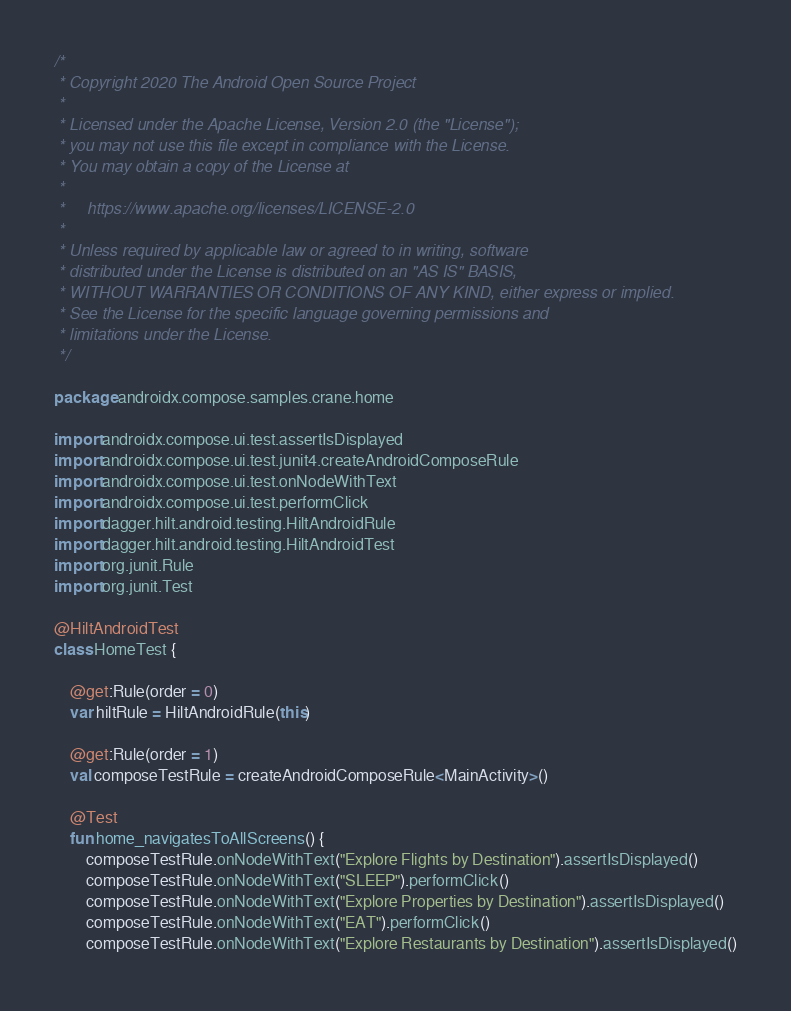<code> <loc_0><loc_0><loc_500><loc_500><_Kotlin_>/*
 * Copyright 2020 The Android Open Source Project
 *
 * Licensed under the Apache License, Version 2.0 (the "License");
 * you may not use this file except in compliance with the License.
 * You may obtain a copy of the License at
 *
 *     https://www.apache.org/licenses/LICENSE-2.0
 *
 * Unless required by applicable law or agreed to in writing, software
 * distributed under the License is distributed on an "AS IS" BASIS,
 * WITHOUT WARRANTIES OR CONDITIONS OF ANY KIND, either express or implied.
 * See the License for the specific language governing permissions and
 * limitations under the License.
 */

package androidx.compose.samples.crane.home

import androidx.compose.ui.test.assertIsDisplayed
import androidx.compose.ui.test.junit4.createAndroidComposeRule
import androidx.compose.ui.test.onNodeWithText
import androidx.compose.ui.test.performClick
import dagger.hilt.android.testing.HiltAndroidRule
import dagger.hilt.android.testing.HiltAndroidTest
import org.junit.Rule
import org.junit.Test

@HiltAndroidTest
class HomeTest {

    @get:Rule(order = 0)
    var hiltRule = HiltAndroidRule(this)

    @get:Rule(order = 1)
    val composeTestRule = createAndroidComposeRule<MainActivity>()

    @Test
    fun home_navigatesToAllScreens() {
        composeTestRule.onNodeWithText("Explore Flights by Destination").assertIsDisplayed()
        composeTestRule.onNodeWithText("SLEEP").performClick()
        composeTestRule.onNodeWithText("Explore Properties by Destination").assertIsDisplayed()
        composeTestRule.onNodeWithText("EAT").performClick()
        composeTestRule.onNodeWithText("Explore Restaurants by Destination").assertIsDisplayed()</code> 